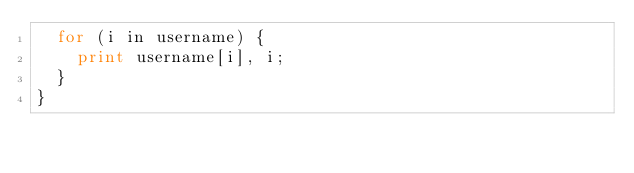<code> <loc_0><loc_0><loc_500><loc_500><_Awk_>	for (i in username) {
		print username[i], i;
	}
}
</code> 